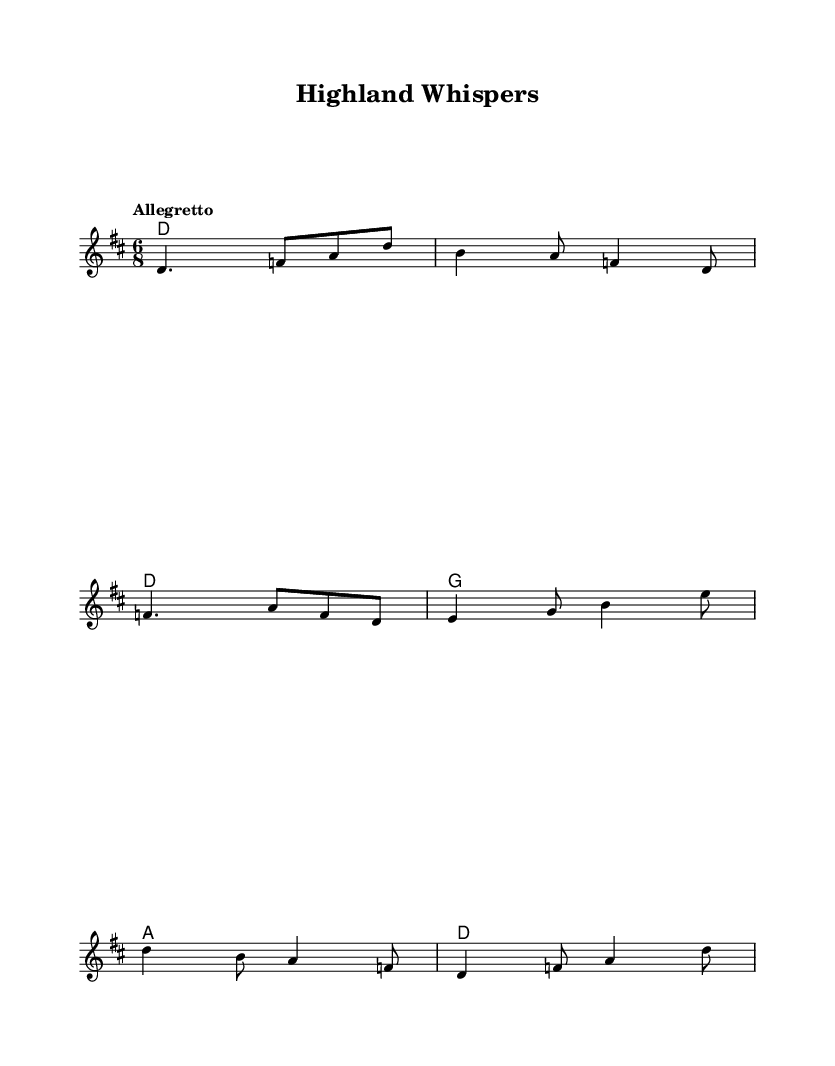What is the time signature of this music? The time signature is indicated as 6/8, which means there are six eighth notes in each measure. This can be found at the beginning of the score.
Answer: 6/8 What is the key signature of this piece? The key signature is D major, which has two sharps: F sharp and C sharp. This is indicated at the beginning of the score within the key signature section.
Answer: D major What is the tempo marking of the piece? The tempo marking is "Allegretto", which indicates a moderately fast tempo. This is explicitly stated above the score in the tempo section.
Answer: Allegretto How many measures are there in the melody? The melody consists of twelve measures. Each measure is visually separated by bar lines, and counting them yields twelve distinct measures.
Answer: 12 What chords are used in the second measure? The chords in the second measure are both D major chords as indicated on the chord staff. The chord symbol repeats the D major chord notation.
Answer: D Which musical style is represented by this sheet music? This sheet music represents the Folk style, particularly influenced by Celtic folk music from Scotland and Ireland, as indicated by the title and musical characteristics such as the use of traditional melodies and rhythms.
Answer: Folk 